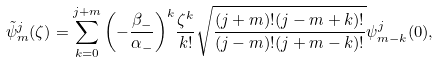<formula> <loc_0><loc_0><loc_500><loc_500>\tilde { \psi } ^ { j } _ { m } ( \zeta ) = \sum _ { k = 0 } ^ { j + m } { \left ( - \frac { \beta _ { - } } { \alpha _ { - } } \right ) } ^ { k } \frac { { \zeta } ^ { k } } { k ! } \sqrt { \frac { ( j + m ) ! ( j - m + k ) ! } { ( j - m ) ! ( j + m - k ) ! } } \psi ^ { j } _ { m - k } ( 0 ) ,</formula> 